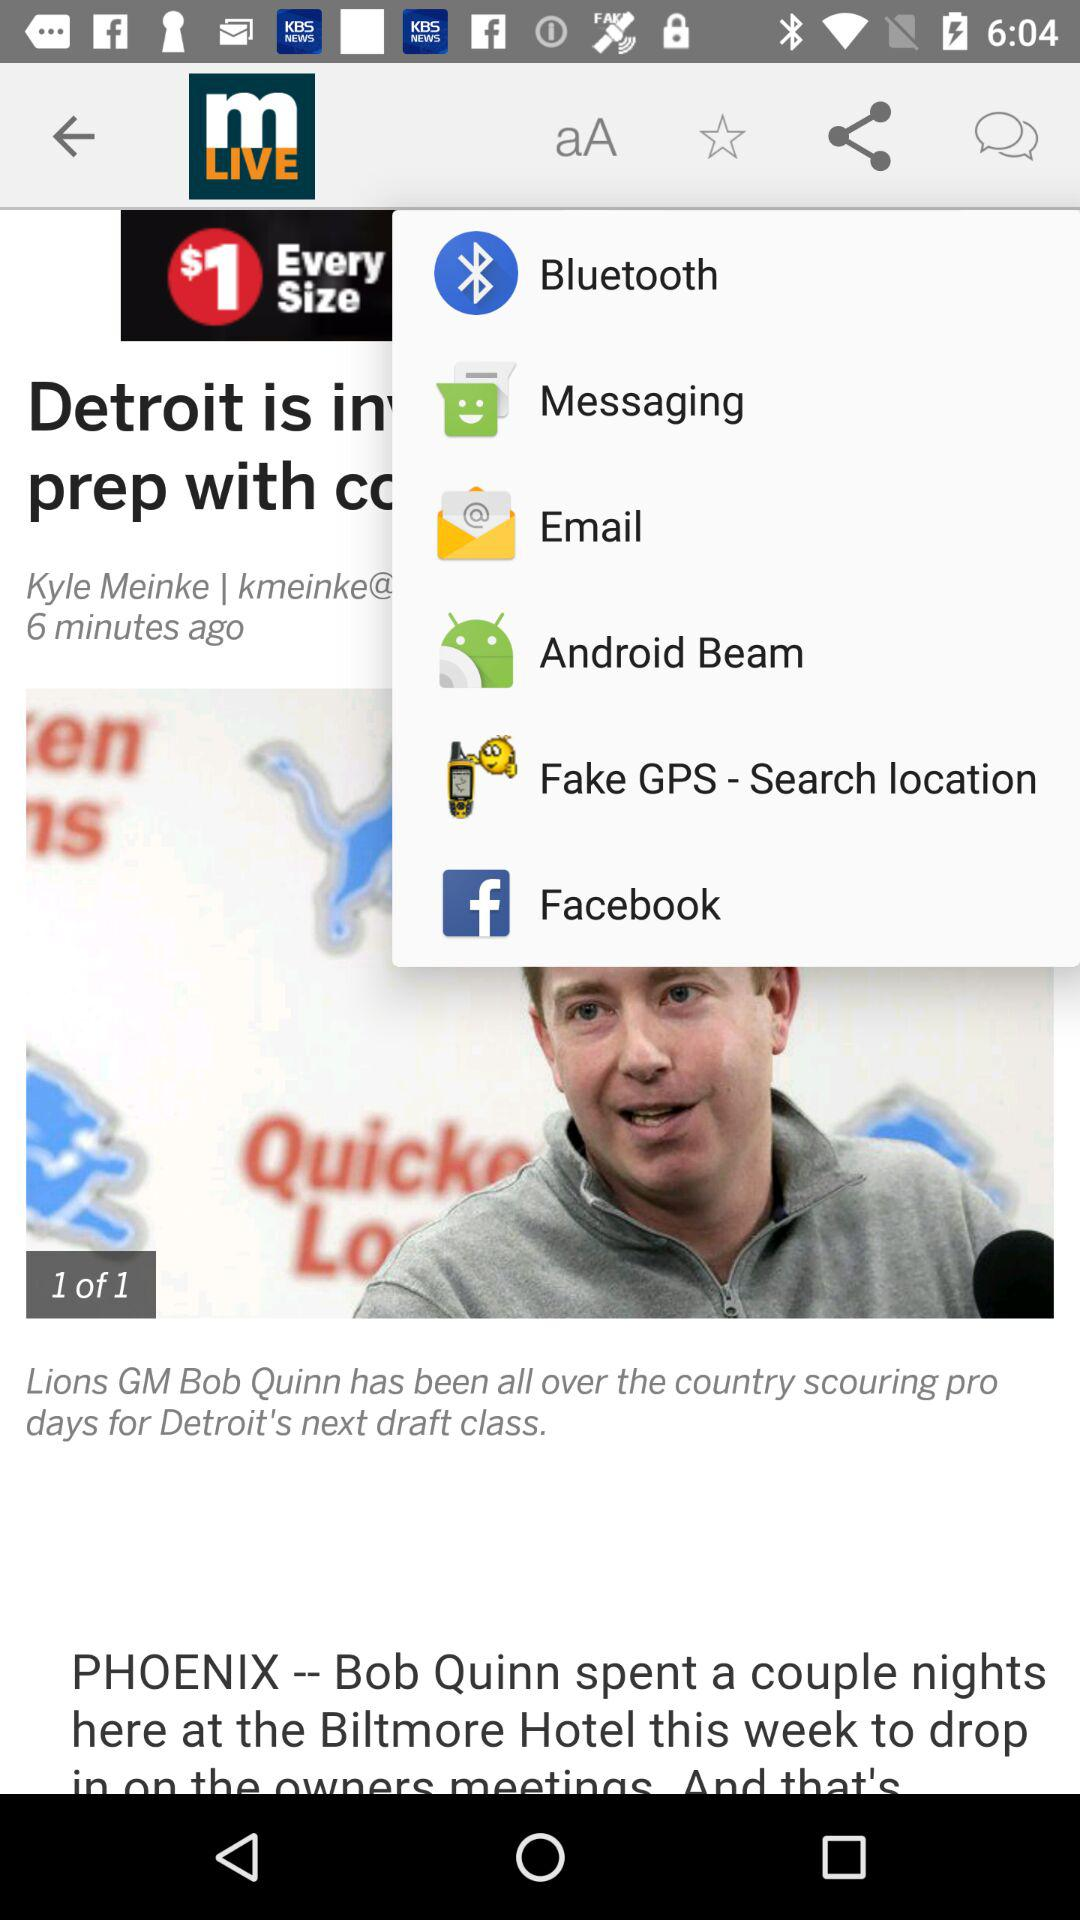How many minutes ago was the article posted? The article was posted 6 minutes ago. 